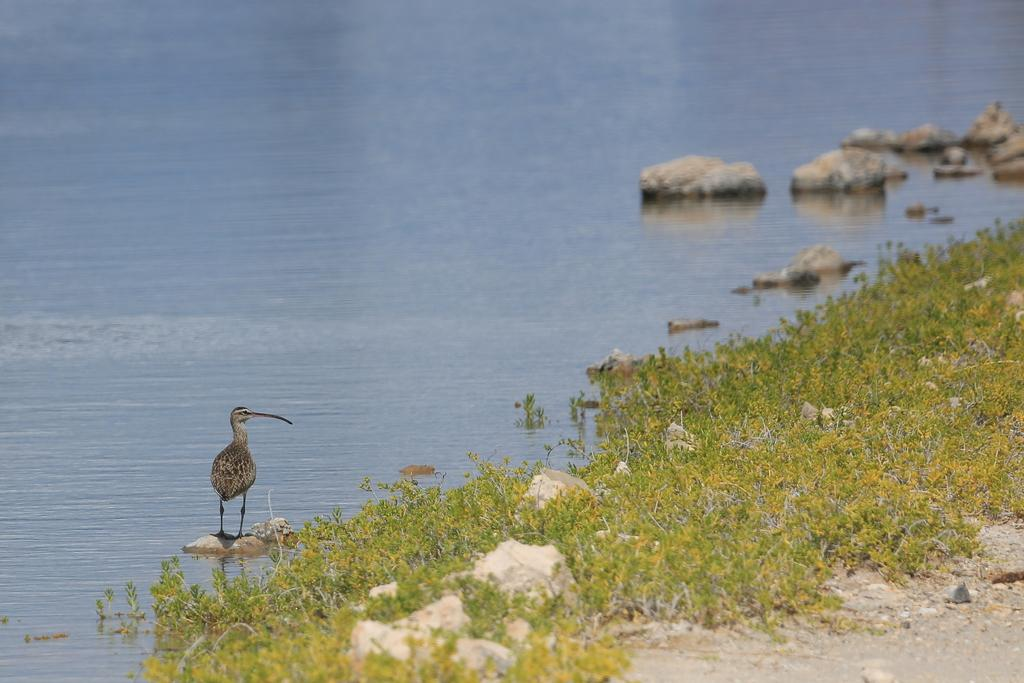What type of vegetation is present in the image? There is grass in the image. What other objects can be seen in the image? There are stones in the image. Where are the stones located in the image? The stones are on the right side of the image. What is sitting on one of the stones in the image? There is a bird on a stone in the image. What can be seen in the background of the image? There is water visible in the background of the image. What type of advertisement can be seen hanging from the icicle in the image? There is no advertisement or icicle present in the image. Is the scene in the image taking place during the night? The image does not provide any information about the time of day, so it cannot be determined if the scene is taking place during the night. 